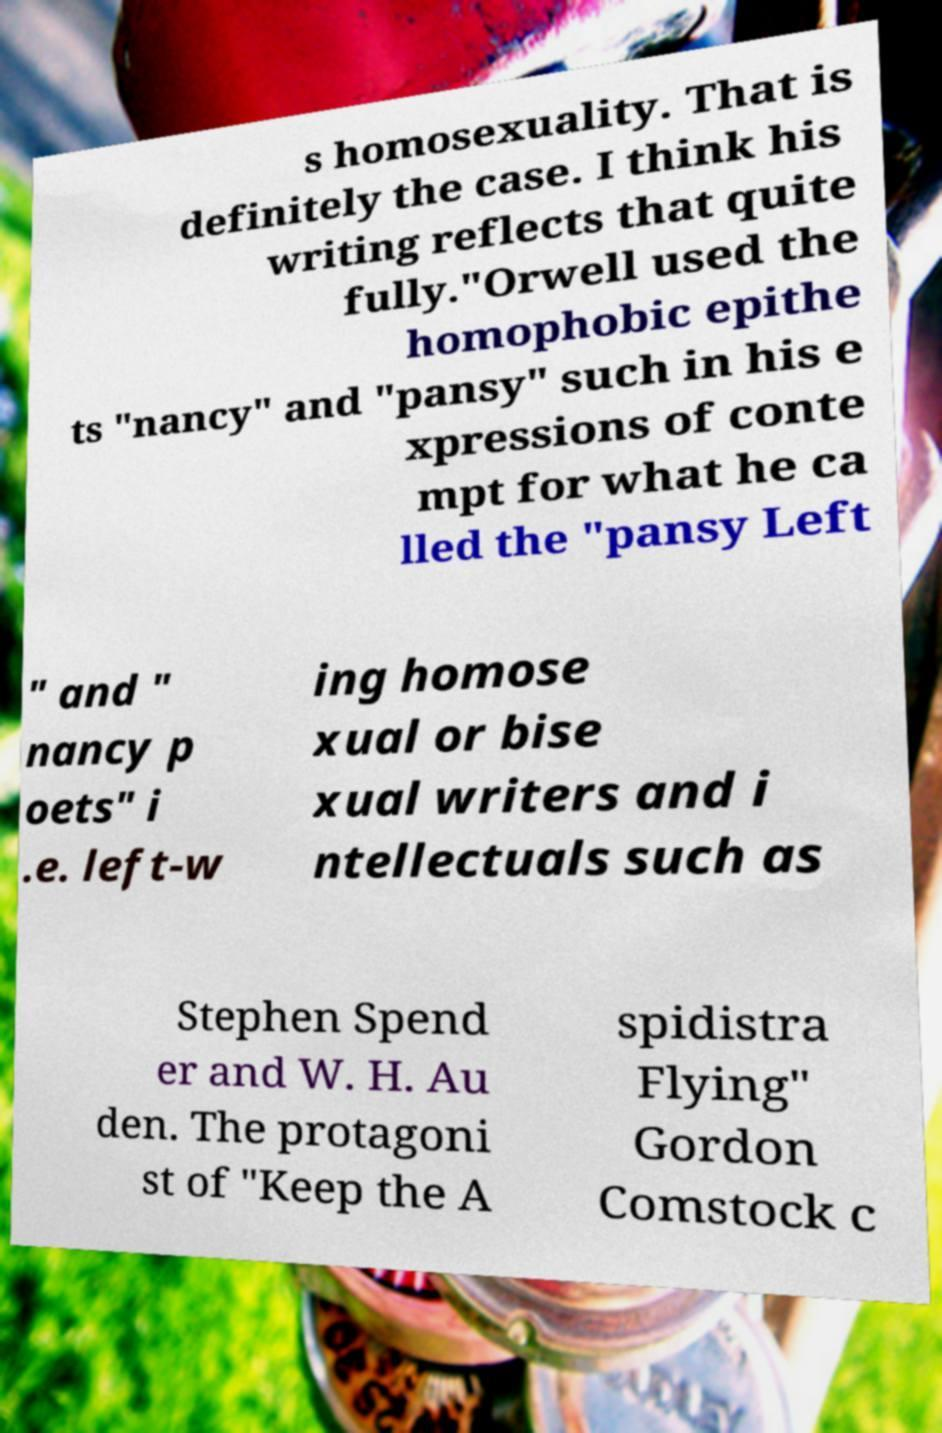Can you read and provide the text displayed in the image?This photo seems to have some interesting text. Can you extract and type it out for me? s homosexuality. That is definitely the case. I think his writing reflects that quite fully."Orwell used the homophobic epithe ts "nancy" and "pansy" such in his e xpressions of conte mpt for what he ca lled the "pansy Left " and " nancy p oets" i .e. left-w ing homose xual or bise xual writers and i ntellectuals such as Stephen Spend er and W. H. Au den. The protagoni st of "Keep the A spidistra Flying" Gordon Comstock c 